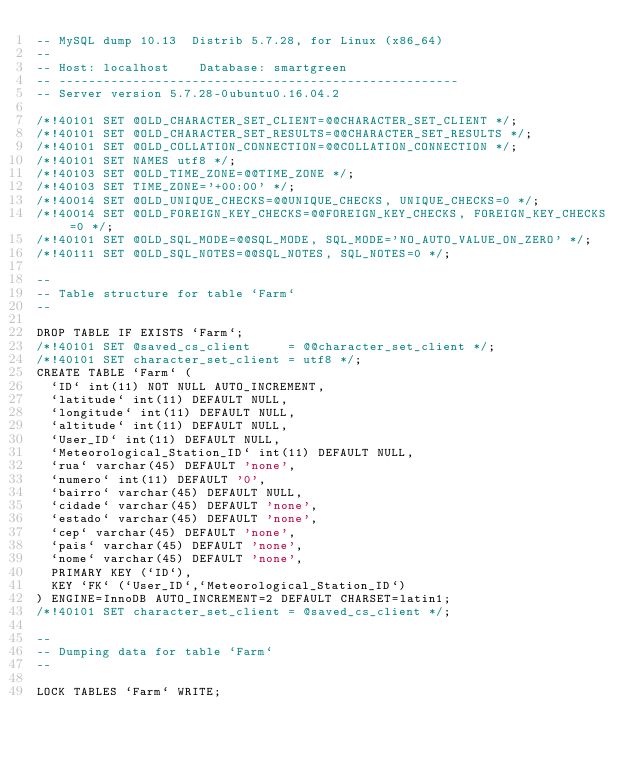<code> <loc_0><loc_0><loc_500><loc_500><_SQL_>-- MySQL dump 10.13  Distrib 5.7.28, for Linux (x86_64)
--
-- Host: localhost    Database: smartgreen
-- ------------------------------------------------------
-- Server version	5.7.28-0ubuntu0.16.04.2

/*!40101 SET @OLD_CHARACTER_SET_CLIENT=@@CHARACTER_SET_CLIENT */;
/*!40101 SET @OLD_CHARACTER_SET_RESULTS=@@CHARACTER_SET_RESULTS */;
/*!40101 SET @OLD_COLLATION_CONNECTION=@@COLLATION_CONNECTION */;
/*!40101 SET NAMES utf8 */;
/*!40103 SET @OLD_TIME_ZONE=@@TIME_ZONE */;
/*!40103 SET TIME_ZONE='+00:00' */;
/*!40014 SET @OLD_UNIQUE_CHECKS=@@UNIQUE_CHECKS, UNIQUE_CHECKS=0 */;
/*!40014 SET @OLD_FOREIGN_KEY_CHECKS=@@FOREIGN_KEY_CHECKS, FOREIGN_KEY_CHECKS=0 */;
/*!40101 SET @OLD_SQL_MODE=@@SQL_MODE, SQL_MODE='NO_AUTO_VALUE_ON_ZERO' */;
/*!40111 SET @OLD_SQL_NOTES=@@SQL_NOTES, SQL_NOTES=0 */;

--
-- Table structure for table `Farm`
--

DROP TABLE IF EXISTS `Farm`;
/*!40101 SET @saved_cs_client     = @@character_set_client */;
/*!40101 SET character_set_client = utf8 */;
CREATE TABLE `Farm` (
  `ID` int(11) NOT NULL AUTO_INCREMENT,
  `latitude` int(11) DEFAULT NULL,
  `longitude` int(11) DEFAULT NULL,
  `altitude` int(11) DEFAULT NULL,
  `User_ID` int(11) DEFAULT NULL,
  `Meteorological_Station_ID` int(11) DEFAULT NULL,
  `rua` varchar(45) DEFAULT 'none',
  `numero` int(11) DEFAULT '0',
  `bairro` varchar(45) DEFAULT NULL,
  `cidade` varchar(45) DEFAULT 'none',
  `estado` varchar(45) DEFAULT 'none',
  `cep` varchar(45) DEFAULT 'none',
  `pais` varchar(45) DEFAULT 'none',
  `nome` varchar(45) DEFAULT 'none',
  PRIMARY KEY (`ID`),
  KEY `FK` (`User_ID`,`Meteorological_Station_ID`)
) ENGINE=InnoDB AUTO_INCREMENT=2 DEFAULT CHARSET=latin1;
/*!40101 SET character_set_client = @saved_cs_client */;

--
-- Dumping data for table `Farm`
--

LOCK TABLES `Farm` WRITE;</code> 